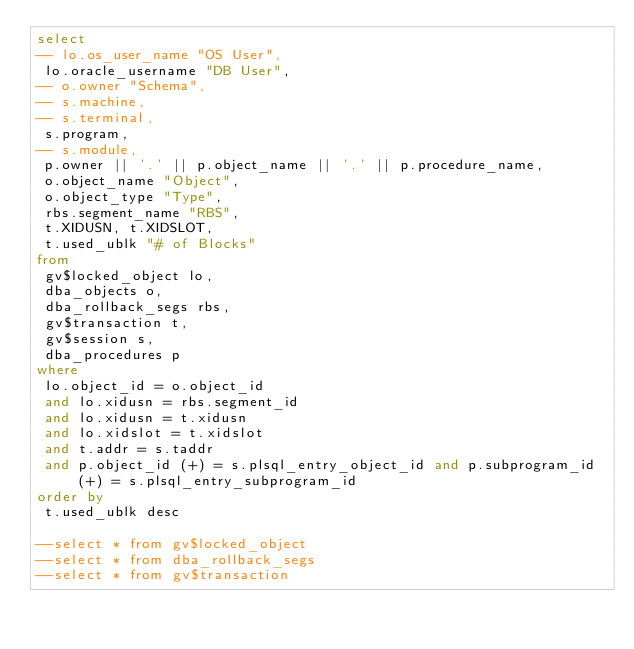Convert code to text. <code><loc_0><loc_0><loc_500><loc_500><_SQL_>select
-- lo.os_user_name "OS User",
 lo.oracle_username "DB User", 
-- o.owner "Schema",
-- s.machine,
-- s.terminal,
 s.program,
-- s.module,
 p.owner || '.' || p.object_name || '.' || p.procedure_name,
 o.object_name "Object", 
 o.object_type "Type", 
 rbs.segment_name "RBS",
 t.XIDUSN, t.XIDSLOT, 
 t.used_ublk "# of Blocks" 
from
 gv$locked_object lo,
 dba_objects o,
 dba_rollback_segs rbs,
 gv$transaction t,
 gv$session s, 
 dba_procedures p
where
 lo.object_id = o.object_id 
 and lo.xidusn = rbs.segment_id 
 and lo.xidusn = t.xidusn 
 and lo.xidslot = t.xidslot 
 and t.addr = s.taddr 
 and p.object_id (+) = s.plsql_entry_object_id and p.subprogram_id (+) = s.plsql_entry_subprogram_id
order by 
 t.used_ublk desc

--select * from gv$locked_object
--select * from dba_rollback_segs
--select * from gv$transaction
</code> 